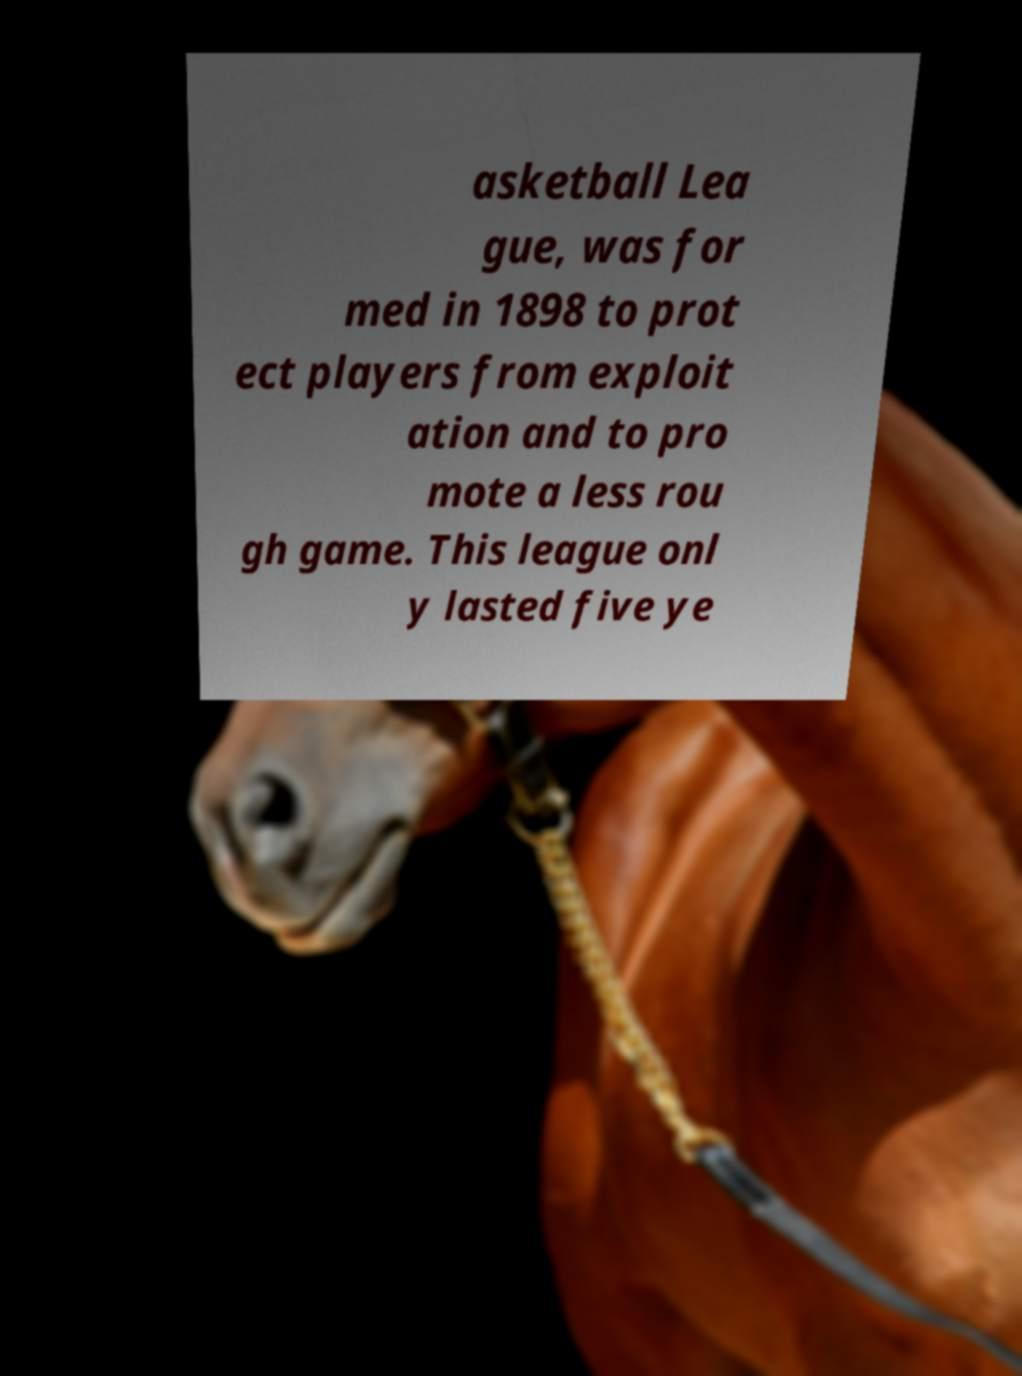Please read and relay the text visible in this image. What does it say? asketball Lea gue, was for med in 1898 to prot ect players from exploit ation and to pro mote a less rou gh game. This league onl y lasted five ye 